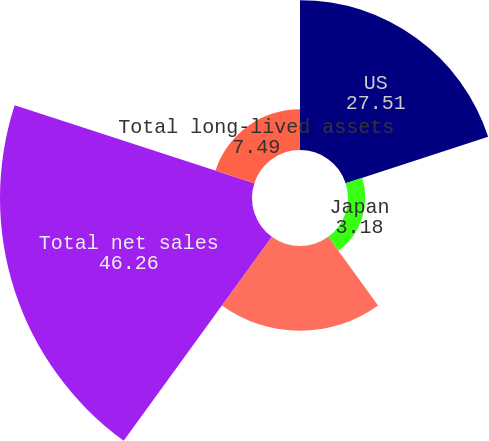<chart> <loc_0><loc_0><loc_500><loc_500><pie_chart><fcel>US<fcel>Japan<fcel>Other countries<fcel>Total net sales<fcel>Total long-lived assets<nl><fcel>27.51%<fcel>3.18%<fcel>15.57%<fcel>46.26%<fcel>7.49%<nl></chart> 